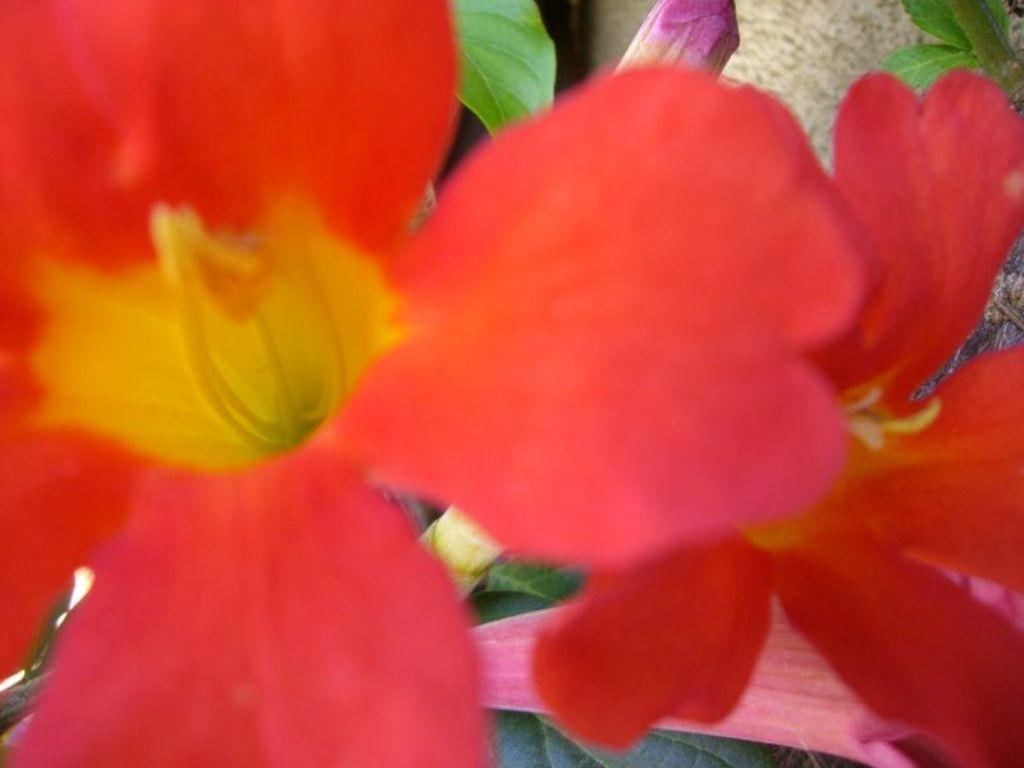What type of plant life is visible in the image? There are flowers in the image. What else can be seen in the background of the image? There are leaves in the background of the image. Are there any unopened flowers visible in the image? Yes, there is at least one flower bud in the background of the image. What type of pen is being used to draw the flowers in the image? There is no pen or drawing activity present in the image; it features real flowers and leaves. 